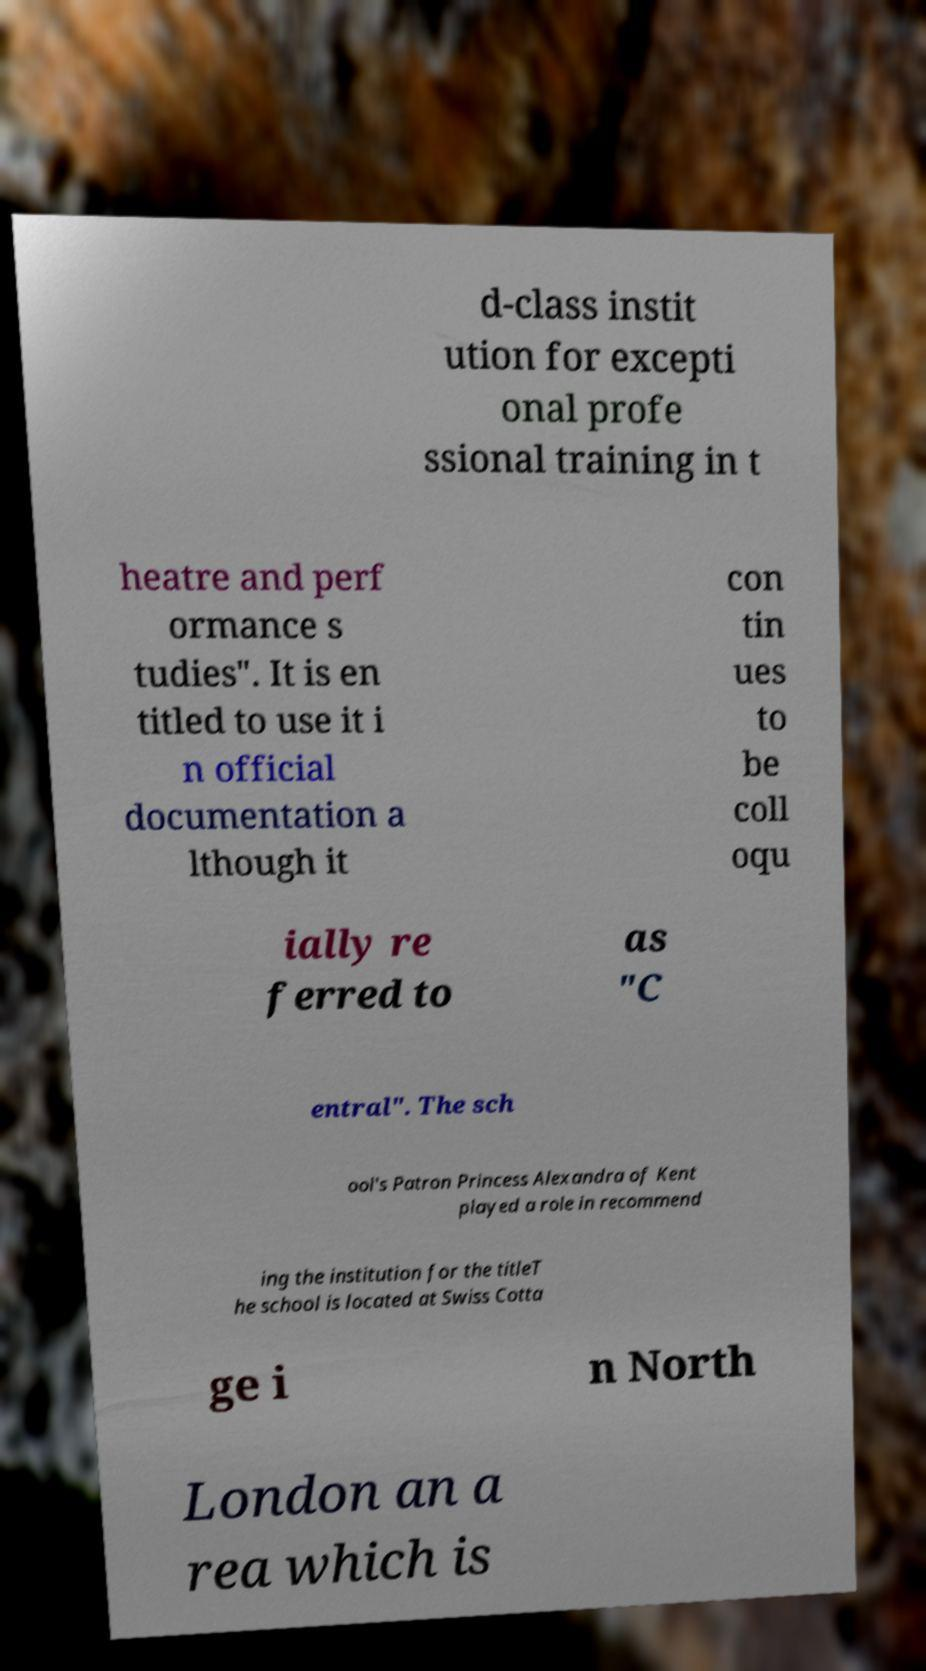I need the written content from this picture converted into text. Can you do that? d-class instit ution for excepti onal profe ssional training in t heatre and perf ormance s tudies". It is en titled to use it i n official documentation a lthough it con tin ues to be coll oqu ially re ferred to as "C entral". The sch ool's Patron Princess Alexandra of Kent played a role in recommend ing the institution for the titleT he school is located at Swiss Cotta ge i n North London an a rea which is 